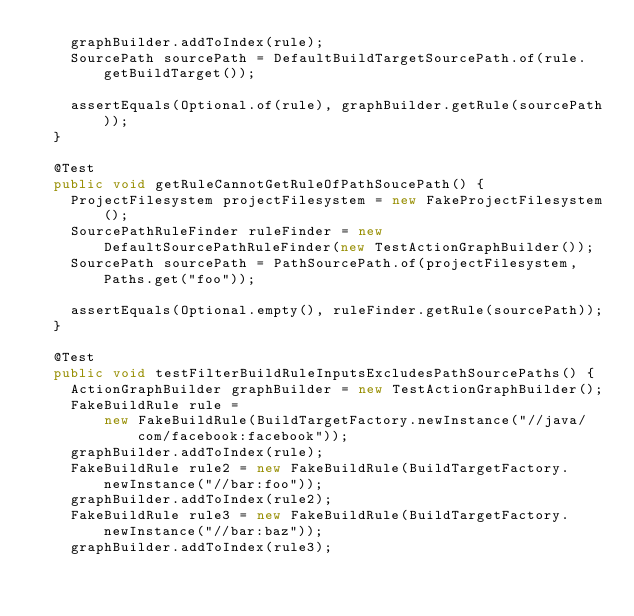Convert code to text. <code><loc_0><loc_0><loc_500><loc_500><_Java_>    graphBuilder.addToIndex(rule);
    SourcePath sourcePath = DefaultBuildTargetSourcePath.of(rule.getBuildTarget());

    assertEquals(Optional.of(rule), graphBuilder.getRule(sourcePath));
  }

  @Test
  public void getRuleCannotGetRuleOfPathSoucePath() {
    ProjectFilesystem projectFilesystem = new FakeProjectFilesystem();
    SourcePathRuleFinder ruleFinder = new DefaultSourcePathRuleFinder(new TestActionGraphBuilder());
    SourcePath sourcePath = PathSourcePath.of(projectFilesystem, Paths.get("foo"));

    assertEquals(Optional.empty(), ruleFinder.getRule(sourcePath));
  }

  @Test
  public void testFilterBuildRuleInputsExcludesPathSourcePaths() {
    ActionGraphBuilder graphBuilder = new TestActionGraphBuilder();
    FakeBuildRule rule =
        new FakeBuildRule(BuildTargetFactory.newInstance("//java/com/facebook:facebook"));
    graphBuilder.addToIndex(rule);
    FakeBuildRule rule2 = new FakeBuildRule(BuildTargetFactory.newInstance("//bar:foo"));
    graphBuilder.addToIndex(rule2);
    FakeBuildRule rule3 = new FakeBuildRule(BuildTargetFactory.newInstance("//bar:baz"));
    graphBuilder.addToIndex(rule3);
</code> 